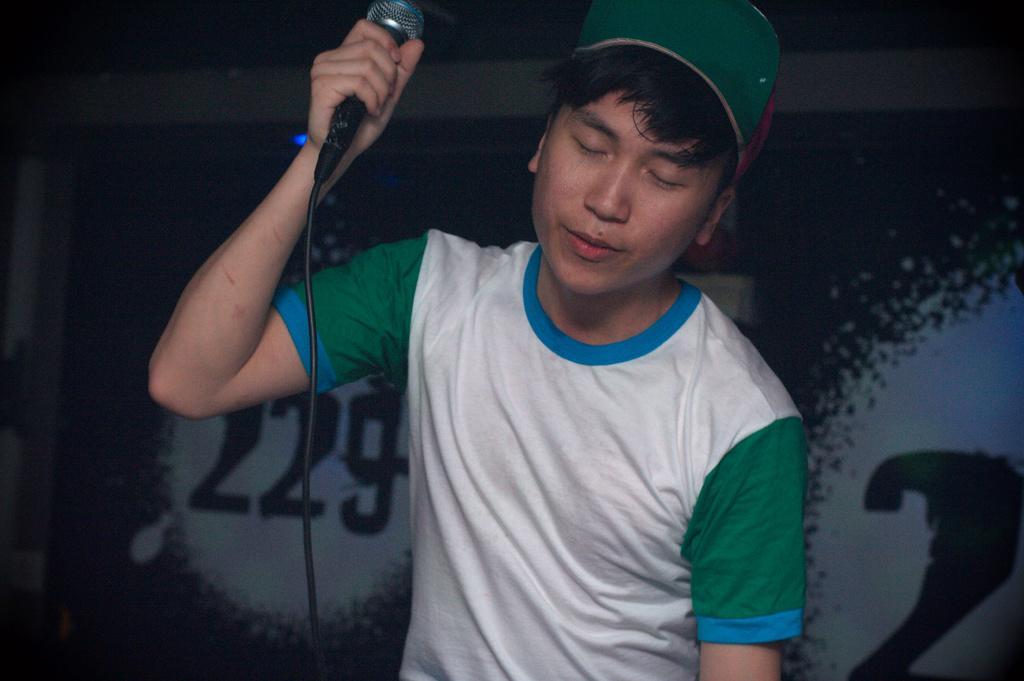In one or two sentences, can you explain what this image depicts? This person holding microphone and wear cap. On the background we can see banner. 